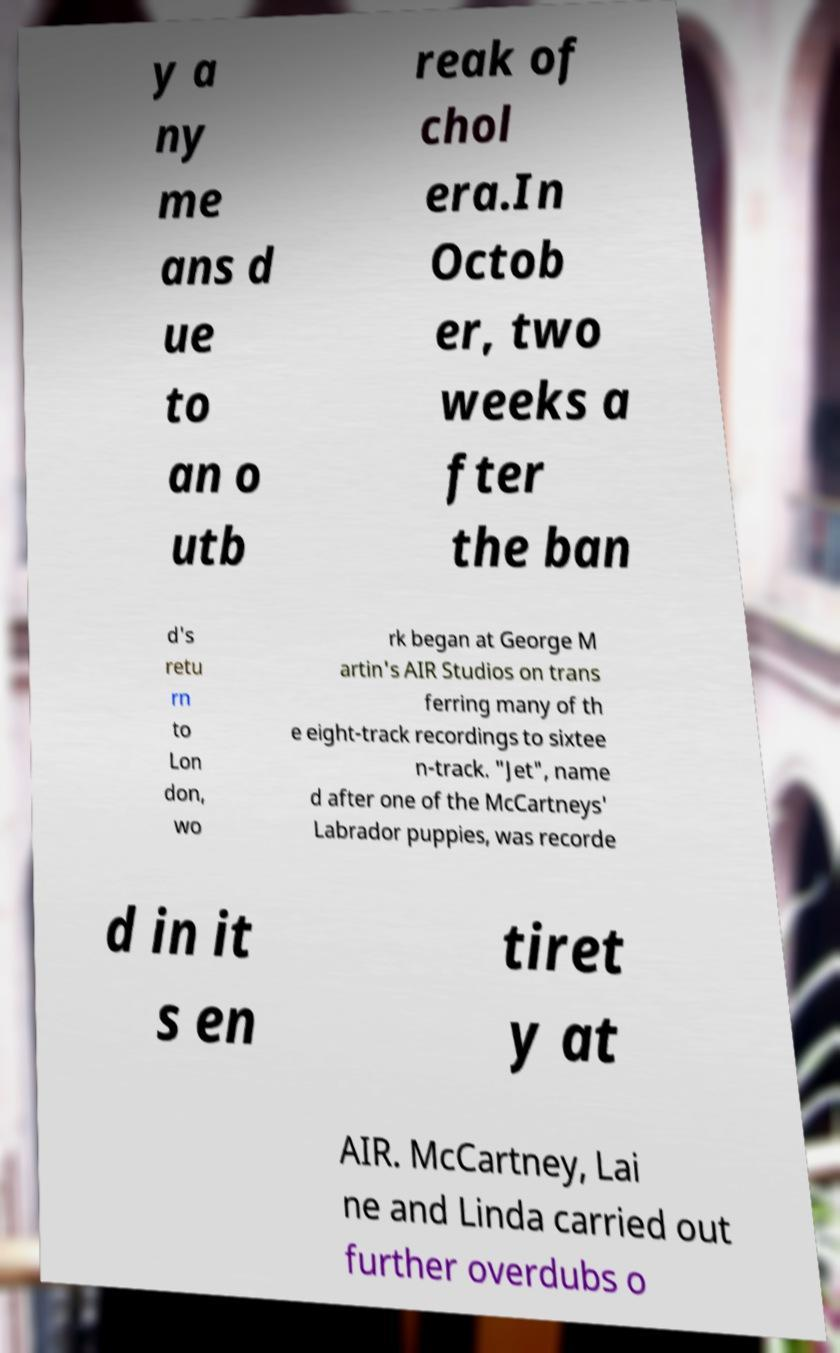Please read and relay the text visible in this image. What does it say? y a ny me ans d ue to an o utb reak of chol era.In Octob er, two weeks a fter the ban d's retu rn to Lon don, wo rk began at George M artin's AIR Studios on trans ferring many of th e eight-track recordings to sixtee n-track. "Jet", name d after one of the McCartneys' Labrador puppies, was recorde d in it s en tiret y at AIR. McCartney, Lai ne and Linda carried out further overdubs o 